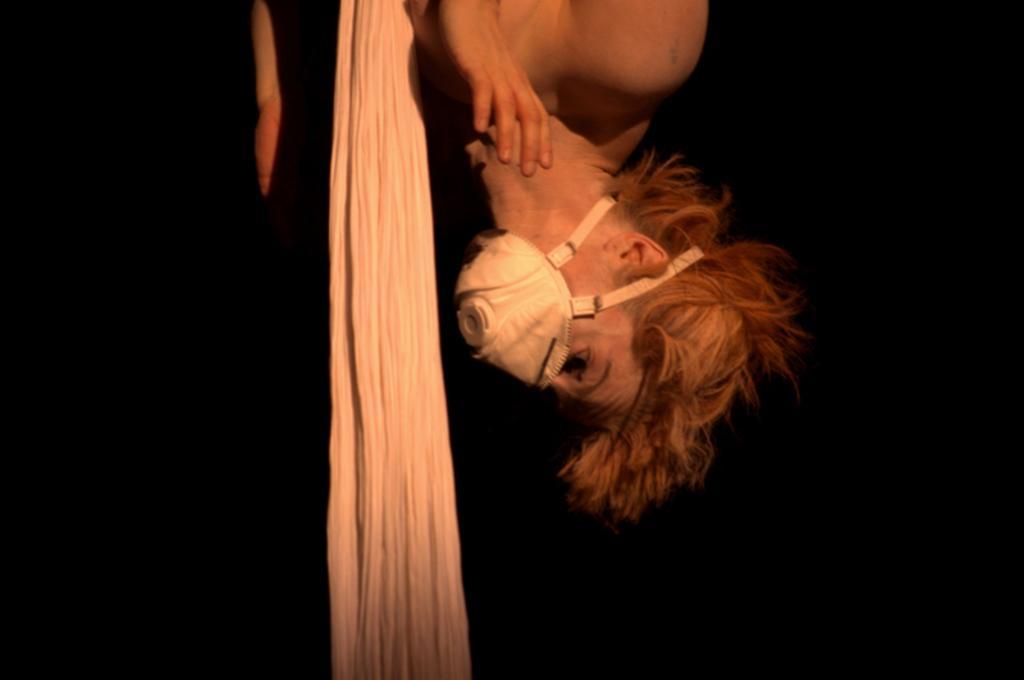Can you describe this image briefly? In this picture I can see there is a woman and she is wearing a mask and there is a cloth beside her and the backdrop is dark. 